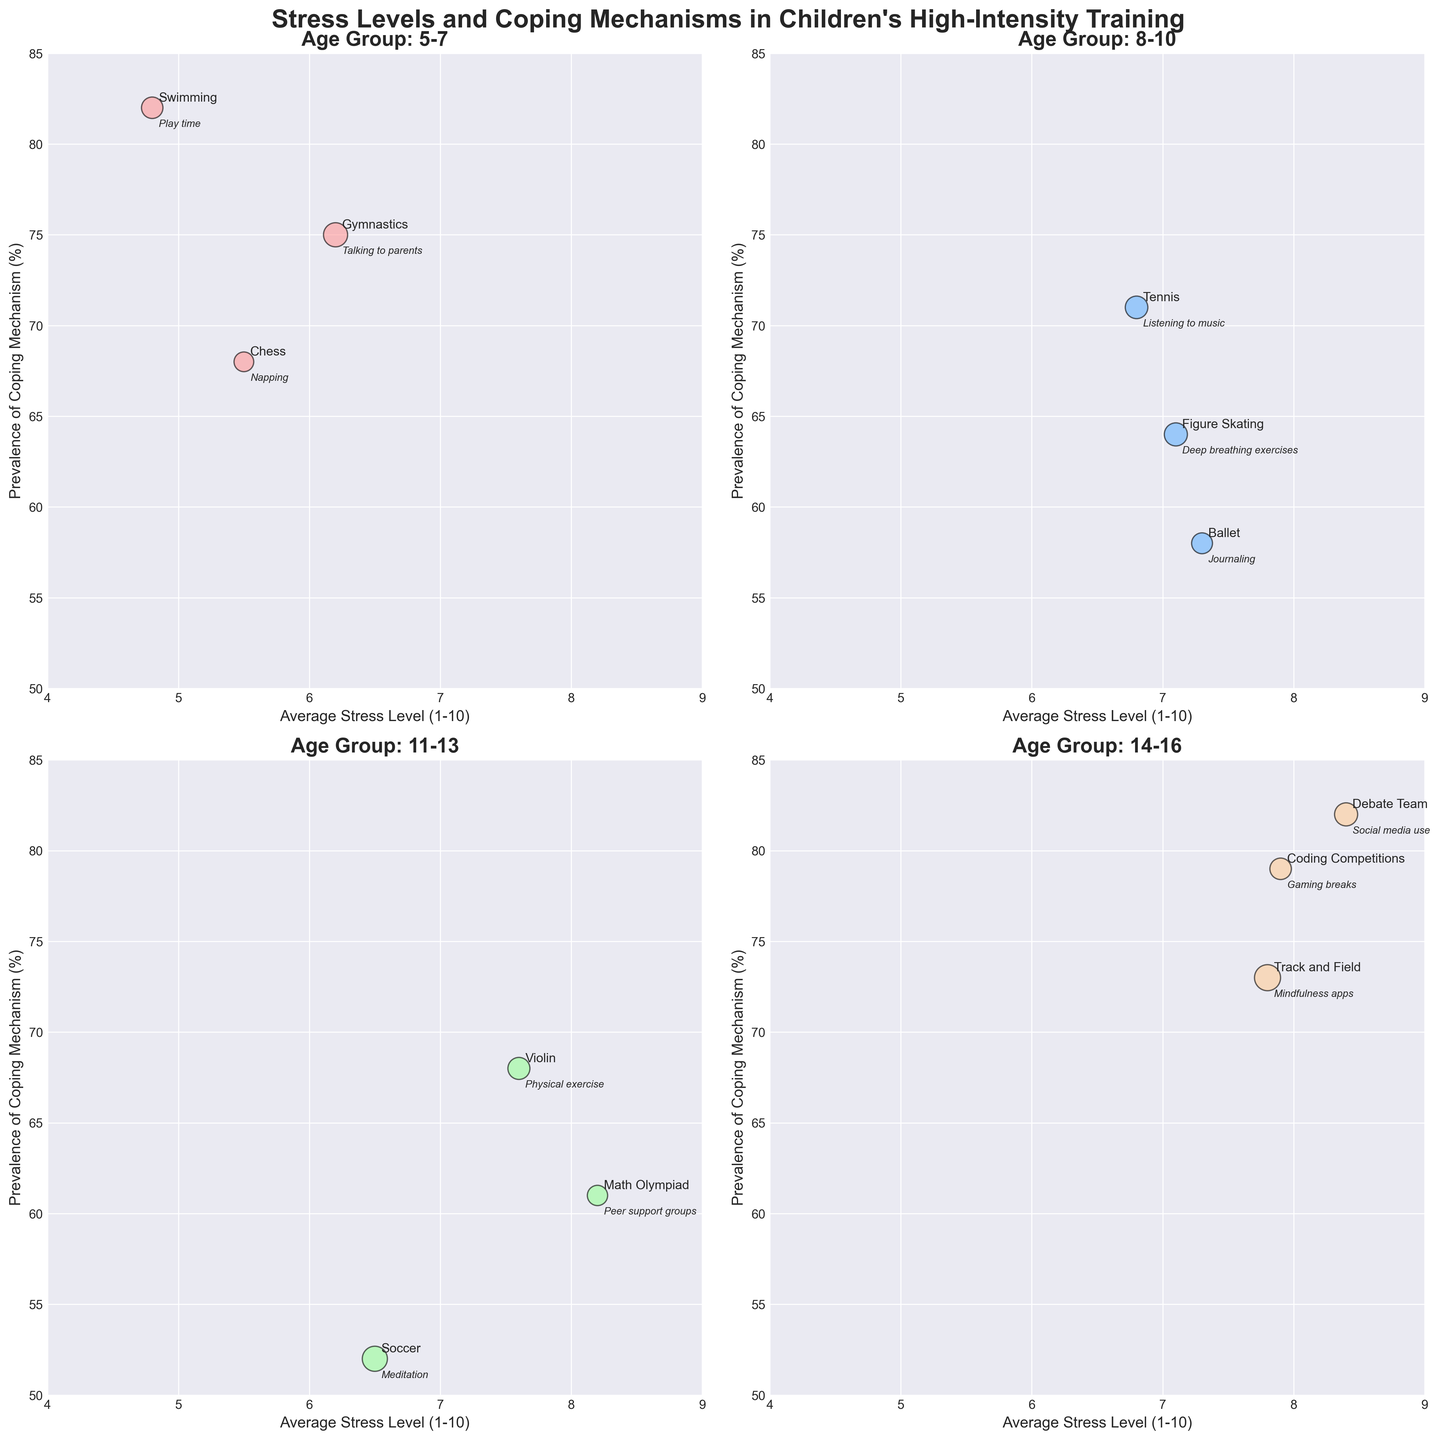Which age group has the highest average stress level? In the figure, look for the bubble with the highest average stress level on the x-axis. For age groups, this is the subplot with "Age Group: 14-16". The "Debate Team" in this group has an average stress level of 8.4, which is the highest among all groups.
Answer: 14-16 What is the common coping mechanism for children aged 5-7 doing Chess? In the subplot for age group 5-7, find the bubble labeled "Chess". The text near the bubble indicates the common coping mechanism as "Napping".
Answer: Napping Which training type in the 11-13 age group has the lowest prevalence of coping mechanism? In the subplot for age group 11-13, compare the y-axis values. The "Soccer" bubble has the lowest prevalence value at 52%.
Answer: Soccer What is the difference in average stress levels between children in Math Olympiad (11-13) and Debate Team (14-16)? Compare the average stress levels given along the x-axis in their respective subplots. Math Olympiad has a stress level of 8.2, and Debate Team has 8.4. The difference is 8.4 - 8.2 = 0.2.
Answer: 0.2 Which training type has the largest sample size in the figure? Observe the size of the bubbles; larger bubbles represent larger sample sizes. The largest bubble corresponds to "Track and Field" in the 14-16 age group with a sample size of 140.
Answer: Track and Field How does the prevalence of coping mechanisms for Swimming (5-7) compare to Track and Field (14-16)? In the respective subplots, Swimming has a prevalence of 82% and Track and Field has 73%. Swimming has a higher prevalence.
Answer: Swimming has a higher prevalence What is the average prevalence of coping mechanisms for all training types in the 8-10 age group? Sum the prevalence percentages of all bubbles in the 8-10 subplot and divide by the number of bubbles. The sum is 64% (Figure Skating) + 71% (Tennis) + 58% (Ballet) = 193. The average is 193 / 3 ≈ 64.33%.
Answer: 64.33% Which age group has the most diverse coping mechanisms, as evident from their labels? Read the coping mechanisms labeled near each bubble in the subplots. Age group 14-16 has varied mechanisms such as "Mindfulness apps", "Gaming breaks", and "Social media use".
Answer: 14-16 